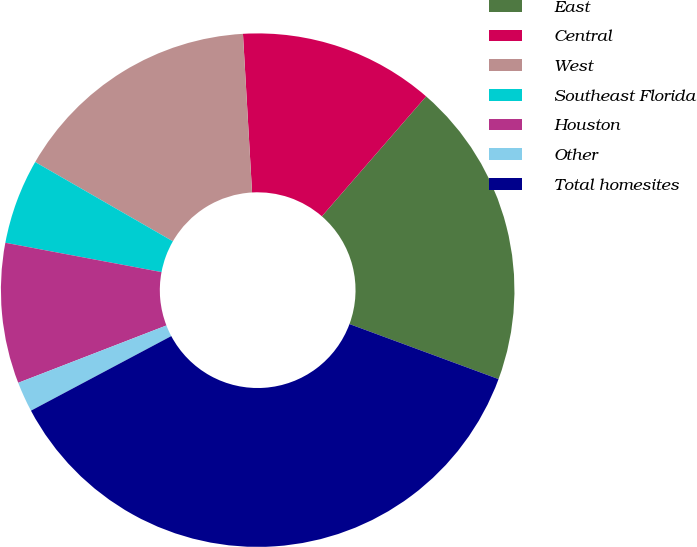Convert chart. <chart><loc_0><loc_0><loc_500><loc_500><pie_chart><fcel>East<fcel>Central<fcel>West<fcel>Southeast Florida<fcel>Houston<fcel>Other<fcel>Total homesites<nl><fcel>19.24%<fcel>12.3%<fcel>15.77%<fcel>5.36%<fcel>8.83%<fcel>1.9%<fcel>36.59%<nl></chart> 